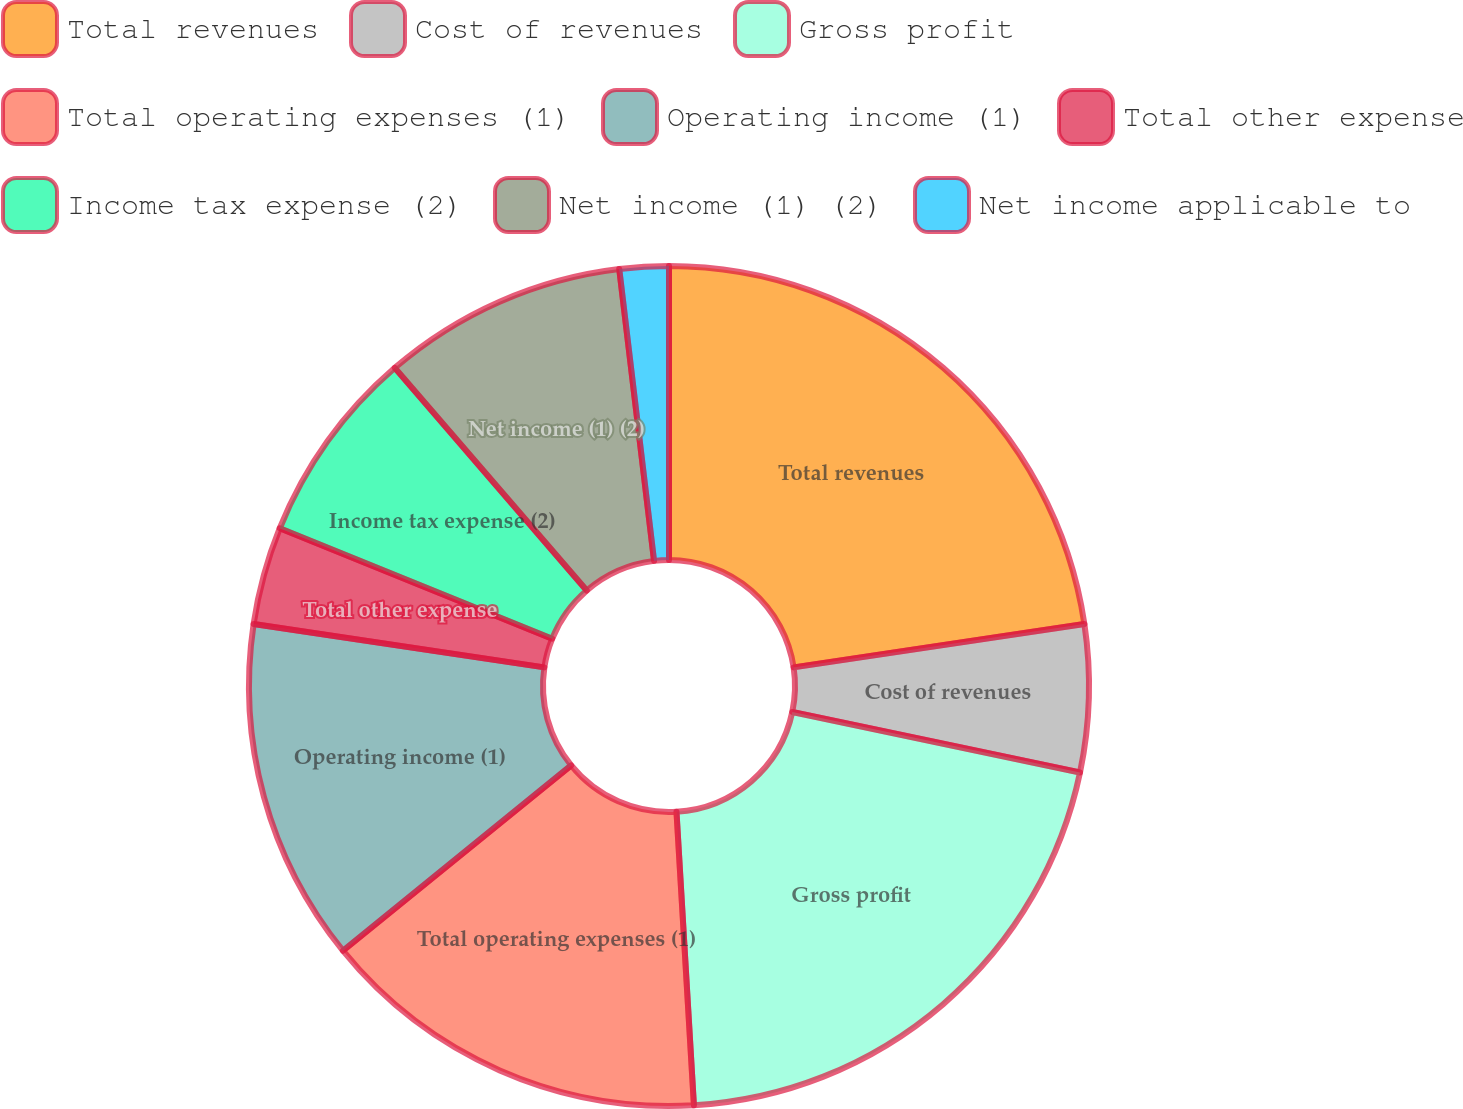Convert chart to OTSL. <chart><loc_0><loc_0><loc_500><loc_500><pie_chart><fcel>Total revenues<fcel>Cost of revenues<fcel>Gross profit<fcel>Total operating expenses (1)<fcel>Operating income (1)<fcel>Total other expense<fcel>Income tax expense (2)<fcel>Net income (1) (2)<fcel>Net income applicable to<nl><fcel>22.64%<fcel>5.66%<fcel>20.75%<fcel>15.09%<fcel>13.21%<fcel>3.77%<fcel>7.55%<fcel>9.43%<fcel>1.89%<nl></chart> 